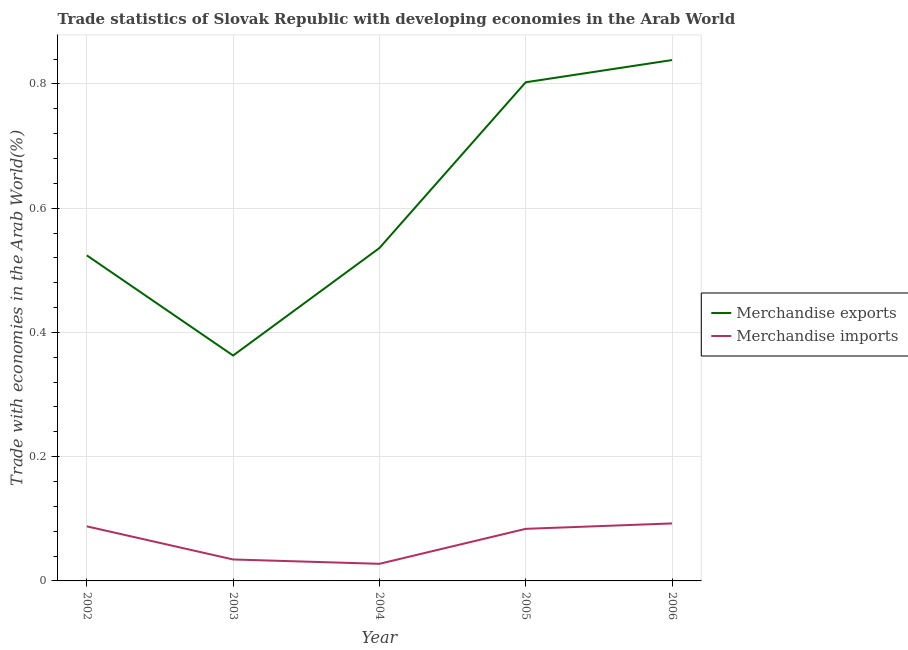What is the merchandise imports in 2002?
Keep it short and to the point. 0.09. Across all years, what is the maximum merchandise exports?
Provide a succinct answer. 0.84. Across all years, what is the minimum merchandise exports?
Provide a short and direct response. 0.36. In which year was the merchandise exports maximum?
Give a very brief answer. 2006. In which year was the merchandise exports minimum?
Your response must be concise. 2003. What is the total merchandise imports in the graph?
Your answer should be very brief. 0.33. What is the difference between the merchandise exports in 2003 and that in 2005?
Your answer should be compact. -0.44. What is the difference between the merchandise imports in 2004 and the merchandise exports in 2006?
Provide a short and direct response. -0.81. What is the average merchandise imports per year?
Provide a short and direct response. 0.07. In the year 2002, what is the difference between the merchandise imports and merchandise exports?
Make the answer very short. -0.44. In how many years, is the merchandise imports greater than 0.6400000000000001 %?
Offer a very short reply. 0. What is the ratio of the merchandise exports in 2005 to that in 2006?
Your answer should be very brief. 0.96. What is the difference between the highest and the second highest merchandise imports?
Provide a short and direct response. 0. What is the difference between the highest and the lowest merchandise imports?
Offer a very short reply. 0.07. In how many years, is the merchandise exports greater than the average merchandise exports taken over all years?
Offer a very short reply. 2. Is the sum of the merchandise imports in 2003 and 2005 greater than the maximum merchandise exports across all years?
Keep it short and to the point. No. Does the merchandise imports monotonically increase over the years?
Make the answer very short. No. How many lines are there?
Your answer should be very brief. 2. What is the difference between two consecutive major ticks on the Y-axis?
Your answer should be very brief. 0.2. Are the values on the major ticks of Y-axis written in scientific E-notation?
Provide a short and direct response. No. Where does the legend appear in the graph?
Offer a terse response. Center right. How are the legend labels stacked?
Give a very brief answer. Vertical. What is the title of the graph?
Your answer should be very brief. Trade statistics of Slovak Republic with developing economies in the Arab World. Does "From Government" appear as one of the legend labels in the graph?
Make the answer very short. No. What is the label or title of the Y-axis?
Ensure brevity in your answer.  Trade with economies in the Arab World(%). What is the Trade with economies in the Arab World(%) of Merchandise exports in 2002?
Offer a terse response. 0.52. What is the Trade with economies in the Arab World(%) of Merchandise imports in 2002?
Ensure brevity in your answer.  0.09. What is the Trade with economies in the Arab World(%) in Merchandise exports in 2003?
Give a very brief answer. 0.36. What is the Trade with economies in the Arab World(%) in Merchandise imports in 2003?
Offer a terse response. 0.03. What is the Trade with economies in the Arab World(%) of Merchandise exports in 2004?
Give a very brief answer. 0.54. What is the Trade with economies in the Arab World(%) of Merchandise imports in 2004?
Provide a short and direct response. 0.03. What is the Trade with economies in the Arab World(%) in Merchandise exports in 2005?
Provide a short and direct response. 0.8. What is the Trade with economies in the Arab World(%) in Merchandise imports in 2005?
Keep it short and to the point. 0.08. What is the Trade with economies in the Arab World(%) of Merchandise exports in 2006?
Give a very brief answer. 0.84. What is the Trade with economies in the Arab World(%) of Merchandise imports in 2006?
Your answer should be compact. 0.09. Across all years, what is the maximum Trade with economies in the Arab World(%) in Merchandise exports?
Provide a short and direct response. 0.84. Across all years, what is the maximum Trade with economies in the Arab World(%) of Merchandise imports?
Provide a succinct answer. 0.09. Across all years, what is the minimum Trade with economies in the Arab World(%) in Merchandise exports?
Your answer should be compact. 0.36. Across all years, what is the minimum Trade with economies in the Arab World(%) in Merchandise imports?
Provide a succinct answer. 0.03. What is the total Trade with economies in the Arab World(%) in Merchandise exports in the graph?
Offer a terse response. 3.06. What is the total Trade with economies in the Arab World(%) of Merchandise imports in the graph?
Provide a succinct answer. 0.33. What is the difference between the Trade with economies in the Arab World(%) of Merchandise exports in 2002 and that in 2003?
Provide a short and direct response. 0.16. What is the difference between the Trade with economies in the Arab World(%) in Merchandise imports in 2002 and that in 2003?
Keep it short and to the point. 0.05. What is the difference between the Trade with economies in the Arab World(%) in Merchandise exports in 2002 and that in 2004?
Offer a terse response. -0.01. What is the difference between the Trade with economies in the Arab World(%) of Merchandise imports in 2002 and that in 2004?
Ensure brevity in your answer.  0.06. What is the difference between the Trade with economies in the Arab World(%) in Merchandise exports in 2002 and that in 2005?
Your answer should be very brief. -0.28. What is the difference between the Trade with economies in the Arab World(%) of Merchandise imports in 2002 and that in 2005?
Your answer should be compact. 0. What is the difference between the Trade with economies in the Arab World(%) of Merchandise exports in 2002 and that in 2006?
Give a very brief answer. -0.31. What is the difference between the Trade with economies in the Arab World(%) in Merchandise imports in 2002 and that in 2006?
Your answer should be very brief. -0. What is the difference between the Trade with economies in the Arab World(%) in Merchandise exports in 2003 and that in 2004?
Offer a very short reply. -0.17. What is the difference between the Trade with economies in the Arab World(%) in Merchandise imports in 2003 and that in 2004?
Ensure brevity in your answer.  0.01. What is the difference between the Trade with economies in the Arab World(%) in Merchandise exports in 2003 and that in 2005?
Provide a succinct answer. -0.44. What is the difference between the Trade with economies in the Arab World(%) in Merchandise imports in 2003 and that in 2005?
Keep it short and to the point. -0.05. What is the difference between the Trade with economies in the Arab World(%) in Merchandise exports in 2003 and that in 2006?
Your answer should be compact. -0.48. What is the difference between the Trade with economies in the Arab World(%) of Merchandise imports in 2003 and that in 2006?
Make the answer very short. -0.06. What is the difference between the Trade with economies in the Arab World(%) of Merchandise exports in 2004 and that in 2005?
Give a very brief answer. -0.27. What is the difference between the Trade with economies in the Arab World(%) in Merchandise imports in 2004 and that in 2005?
Your response must be concise. -0.06. What is the difference between the Trade with economies in the Arab World(%) in Merchandise exports in 2004 and that in 2006?
Your response must be concise. -0.3. What is the difference between the Trade with economies in the Arab World(%) in Merchandise imports in 2004 and that in 2006?
Your answer should be very brief. -0.07. What is the difference between the Trade with economies in the Arab World(%) of Merchandise exports in 2005 and that in 2006?
Your answer should be compact. -0.04. What is the difference between the Trade with economies in the Arab World(%) of Merchandise imports in 2005 and that in 2006?
Make the answer very short. -0.01. What is the difference between the Trade with economies in the Arab World(%) of Merchandise exports in 2002 and the Trade with economies in the Arab World(%) of Merchandise imports in 2003?
Provide a short and direct response. 0.49. What is the difference between the Trade with economies in the Arab World(%) in Merchandise exports in 2002 and the Trade with economies in the Arab World(%) in Merchandise imports in 2004?
Give a very brief answer. 0.5. What is the difference between the Trade with economies in the Arab World(%) of Merchandise exports in 2002 and the Trade with economies in the Arab World(%) of Merchandise imports in 2005?
Keep it short and to the point. 0.44. What is the difference between the Trade with economies in the Arab World(%) of Merchandise exports in 2002 and the Trade with economies in the Arab World(%) of Merchandise imports in 2006?
Offer a terse response. 0.43. What is the difference between the Trade with economies in the Arab World(%) in Merchandise exports in 2003 and the Trade with economies in the Arab World(%) in Merchandise imports in 2004?
Offer a very short reply. 0.34. What is the difference between the Trade with economies in the Arab World(%) in Merchandise exports in 2003 and the Trade with economies in the Arab World(%) in Merchandise imports in 2005?
Provide a succinct answer. 0.28. What is the difference between the Trade with economies in the Arab World(%) of Merchandise exports in 2003 and the Trade with economies in the Arab World(%) of Merchandise imports in 2006?
Give a very brief answer. 0.27. What is the difference between the Trade with economies in the Arab World(%) of Merchandise exports in 2004 and the Trade with economies in the Arab World(%) of Merchandise imports in 2005?
Your answer should be compact. 0.45. What is the difference between the Trade with economies in the Arab World(%) of Merchandise exports in 2004 and the Trade with economies in the Arab World(%) of Merchandise imports in 2006?
Make the answer very short. 0.44. What is the difference between the Trade with economies in the Arab World(%) of Merchandise exports in 2005 and the Trade with economies in the Arab World(%) of Merchandise imports in 2006?
Provide a short and direct response. 0.71. What is the average Trade with economies in the Arab World(%) of Merchandise exports per year?
Provide a short and direct response. 0.61. What is the average Trade with economies in the Arab World(%) of Merchandise imports per year?
Provide a short and direct response. 0.07. In the year 2002, what is the difference between the Trade with economies in the Arab World(%) in Merchandise exports and Trade with economies in the Arab World(%) in Merchandise imports?
Keep it short and to the point. 0.44. In the year 2003, what is the difference between the Trade with economies in the Arab World(%) in Merchandise exports and Trade with economies in the Arab World(%) in Merchandise imports?
Offer a terse response. 0.33. In the year 2004, what is the difference between the Trade with economies in the Arab World(%) in Merchandise exports and Trade with economies in the Arab World(%) in Merchandise imports?
Offer a terse response. 0.51. In the year 2005, what is the difference between the Trade with economies in the Arab World(%) of Merchandise exports and Trade with economies in the Arab World(%) of Merchandise imports?
Provide a succinct answer. 0.72. In the year 2006, what is the difference between the Trade with economies in the Arab World(%) of Merchandise exports and Trade with economies in the Arab World(%) of Merchandise imports?
Your answer should be compact. 0.75. What is the ratio of the Trade with economies in the Arab World(%) in Merchandise exports in 2002 to that in 2003?
Offer a very short reply. 1.44. What is the ratio of the Trade with economies in the Arab World(%) in Merchandise imports in 2002 to that in 2003?
Provide a short and direct response. 2.54. What is the ratio of the Trade with economies in the Arab World(%) in Merchandise exports in 2002 to that in 2004?
Keep it short and to the point. 0.98. What is the ratio of the Trade with economies in the Arab World(%) of Merchandise imports in 2002 to that in 2004?
Offer a very short reply. 3.19. What is the ratio of the Trade with economies in the Arab World(%) of Merchandise exports in 2002 to that in 2005?
Ensure brevity in your answer.  0.65. What is the ratio of the Trade with economies in the Arab World(%) in Merchandise imports in 2002 to that in 2005?
Offer a very short reply. 1.05. What is the ratio of the Trade with economies in the Arab World(%) in Merchandise exports in 2002 to that in 2006?
Provide a succinct answer. 0.62. What is the ratio of the Trade with economies in the Arab World(%) of Merchandise imports in 2002 to that in 2006?
Provide a succinct answer. 0.95. What is the ratio of the Trade with economies in the Arab World(%) in Merchandise exports in 2003 to that in 2004?
Your response must be concise. 0.68. What is the ratio of the Trade with economies in the Arab World(%) in Merchandise imports in 2003 to that in 2004?
Provide a succinct answer. 1.25. What is the ratio of the Trade with economies in the Arab World(%) of Merchandise exports in 2003 to that in 2005?
Your answer should be very brief. 0.45. What is the ratio of the Trade with economies in the Arab World(%) of Merchandise imports in 2003 to that in 2005?
Give a very brief answer. 0.41. What is the ratio of the Trade with economies in the Arab World(%) in Merchandise exports in 2003 to that in 2006?
Ensure brevity in your answer.  0.43. What is the ratio of the Trade with economies in the Arab World(%) in Merchandise imports in 2003 to that in 2006?
Provide a short and direct response. 0.37. What is the ratio of the Trade with economies in the Arab World(%) of Merchandise exports in 2004 to that in 2005?
Provide a short and direct response. 0.67. What is the ratio of the Trade with economies in the Arab World(%) in Merchandise imports in 2004 to that in 2005?
Offer a terse response. 0.33. What is the ratio of the Trade with economies in the Arab World(%) in Merchandise exports in 2004 to that in 2006?
Keep it short and to the point. 0.64. What is the ratio of the Trade with economies in the Arab World(%) of Merchandise imports in 2004 to that in 2006?
Provide a succinct answer. 0.3. What is the ratio of the Trade with economies in the Arab World(%) in Merchandise exports in 2005 to that in 2006?
Your answer should be compact. 0.96. What is the ratio of the Trade with economies in the Arab World(%) of Merchandise imports in 2005 to that in 2006?
Give a very brief answer. 0.91. What is the difference between the highest and the second highest Trade with economies in the Arab World(%) in Merchandise exports?
Offer a very short reply. 0.04. What is the difference between the highest and the second highest Trade with economies in the Arab World(%) of Merchandise imports?
Your response must be concise. 0. What is the difference between the highest and the lowest Trade with economies in the Arab World(%) in Merchandise exports?
Your answer should be very brief. 0.48. What is the difference between the highest and the lowest Trade with economies in the Arab World(%) in Merchandise imports?
Give a very brief answer. 0.07. 